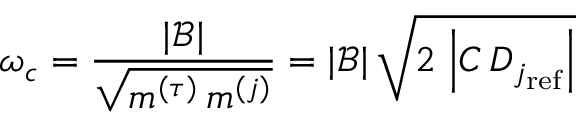Convert formula to latex. <formula><loc_0><loc_0><loc_500><loc_500>\omega _ { c } = \frac { | \mathcal { B } | } { \sqrt { m ^ { ( \tau ) } \, m ^ { ( j ) } } } = | \mathcal { B } | \, \sqrt { 2 \, \left | C \, D _ { j _ { r e f } } \right | }</formula> 